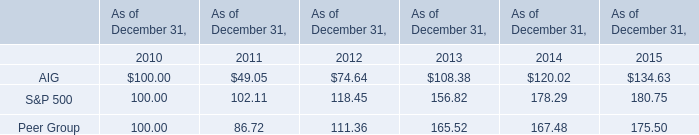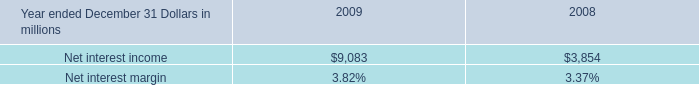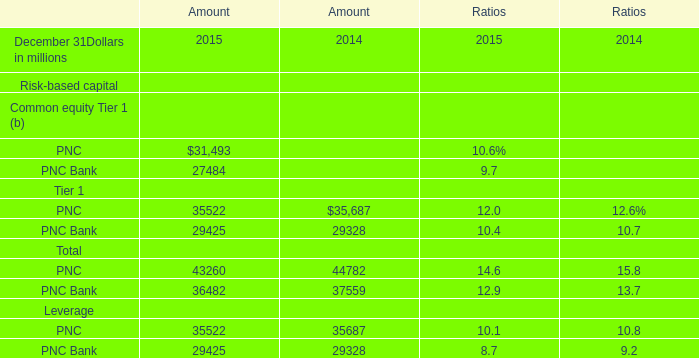what was the average of noninterest income in 2008 and 2009 , in billions? 
Computations: ((7.1 + 2.4) / 2)
Answer: 4.75. 